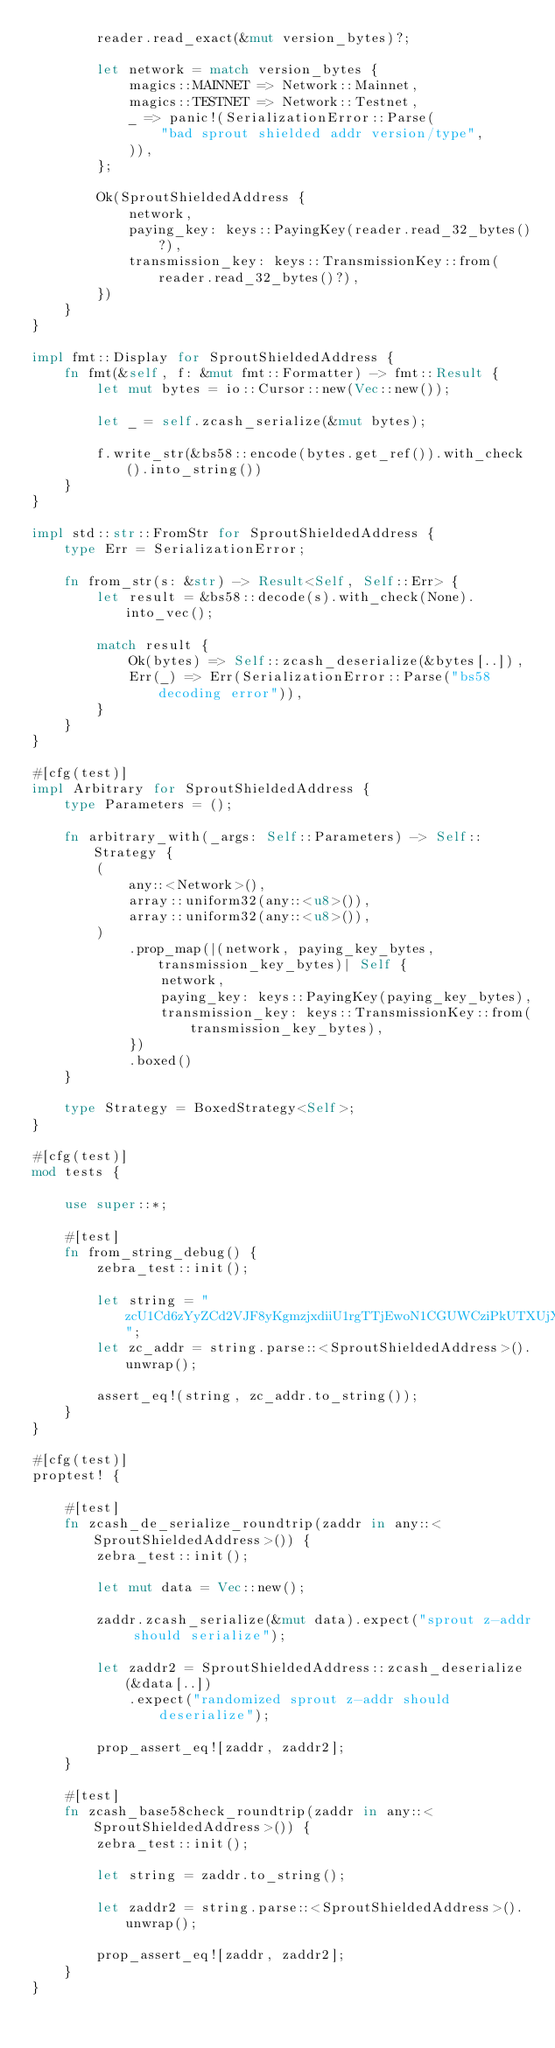Convert code to text. <code><loc_0><loc_0><loc_500><loc_500><_Rust_>        reader.read_exact(&mut version_bytes)?;

        let network = match version_bytes {
            magics::MAINNET => Network::Mainnet,
            magics::TESTNET => Network::Testnet,
            _ => panic!(SerializationError::Parse(
                "bad sprout shielded addr version/type",
            )),
        };

        Ok(SproutShieldedAddress {
            network,
            paying_key: keys::PayingKey(reader.read_32_bytes()?),
            transmission_key: keys::TransmissionKey::from(reader.read_32_bytes()?),
        })
    }
}

impl fmt::Display for SproutShieldedAddress {
    fn fmt(&self, f: &mut fmt::Formatter) -> fmt::Result {
        let mut bytes = io::Cursor::new(Vec::new());

        let _ = self.zcash_serialize(&mut bytes);

        f.write_str(&bs58::encode(bytes.get_ref()).with_check().into_string())
    }
}

impl std::str::FromStr for SproutShieldedAddress {
    type Err = SerializationError;

    fn from_str(s: &str) -> Result<Self, Self::Err> {
        let result = &bs58::decode(s).with_check(None).into_vec();

        match result {
            Ok(bytes) => Self::zcash_deserialize(&bytes[..]),
            Err(_) => Err(SerializationError::Parse("bs58 decoding error")),
        }
    }
}

#[cfg(test)]
impl Arbitrary for SproutShieldedAddress {
    type Parameters = ();

    fn arbitrary_with(_args: Self::Parameters) -> Self::Strategy {
        (
            any::<Network>(),
            array::uniform32(any::<u8>()),
            array::uniform32(any::<u8>()),
        )
            .prop_map(|(network, paying_key_bytes, transmission_key_bytes)| Self {
                network,
                paying_key: keys::PayingKey(paying_key_bytes),
                transmission_key: keys::TransmissionKey::from(transmission_key_bytes),
            })
            .boxed()
    }

    type Strategy = BoxedStrategy<Self>;
}

#[cfg(test)]
mod tests {

    use super::*;

    #[test]
    fn from_string_debug() {
        zebra_test::init();

        let string = "zcU1Cd6zYyZCd2VJF8yKgmzjxdiiU1rgTTjEwoN1CGUWCziPkUTXUjXmX7TMqdMNsTfuiGN1jQoVN4kGxUR4sAPN4XZ7pxb";
        let zc_addr = string.parse::<SproutShieldedAddress>().unwrap();

        assert_eq!(string, zc_addr.to_string());
    }
}

#[cfg(test)]
proptest! {

    #[test]
    fn zcash_de_serialize_roundtrip(zaddr in any::<SproutShieldedAddress>()) {
        zebra_test::init();

        let mut data = Vec::new();

        zaddr.zcash_serialize(&mut data).expect("sprout z-addr should serialize");

        let zaddr2 = SproutShieldedAddress::zcash_deserialize(&data[..])
            .expect("randomized sprout z-addr should deserialize");

        prop_assert_eq![zaddr, zaddr2];
    }

    #[test]
    fn zcash_base58check_roundtrip(zaddr in any::<SproutShieldedAddress>()) {
        zebra_test::init();

        let string = zaddr.to_string();

        let zaddr2 = string.parse::<SproutShieldedAddress>().unwrap();

        prop_assert_eq![zaddr, zaddr2];
    }
}
</code> 